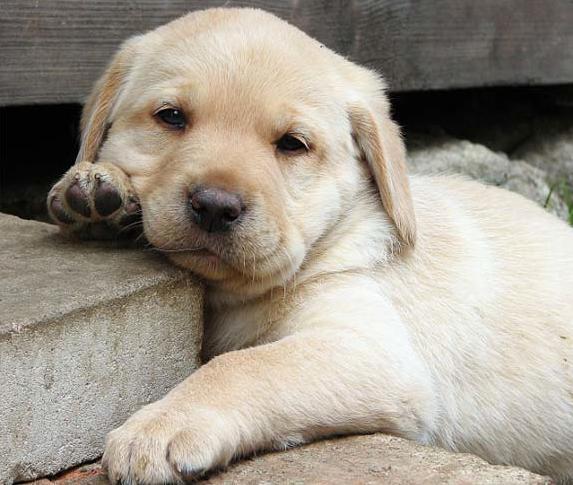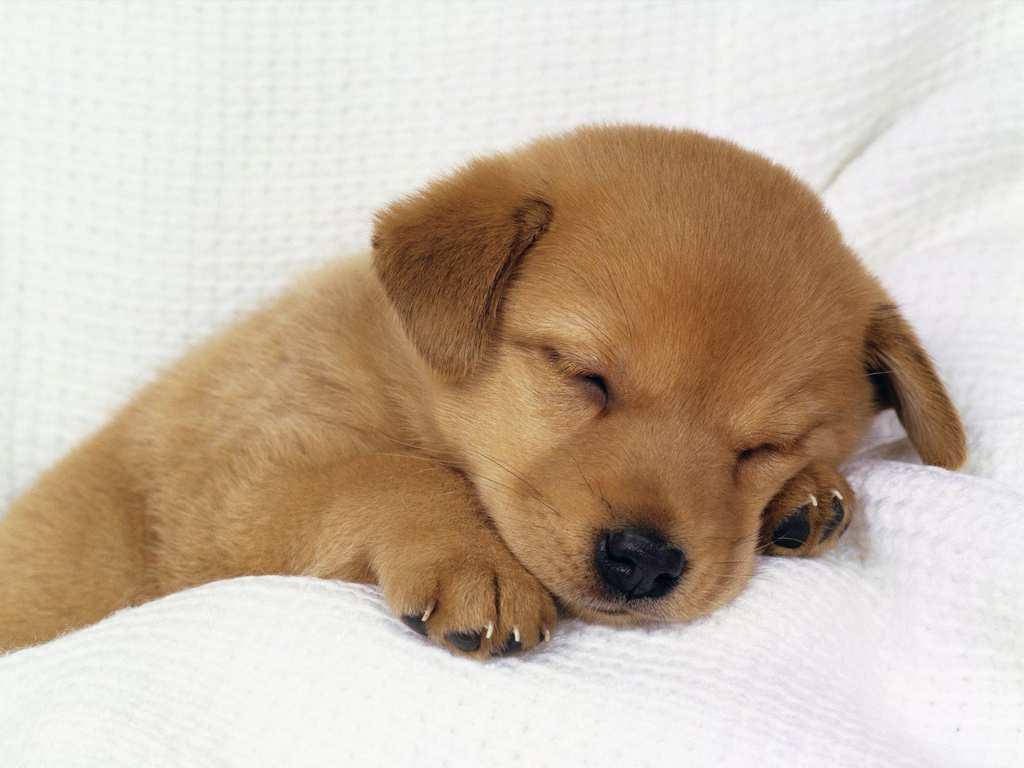The first image is the image on the left, the second image is the image on the right. Evaluate the accuracy of this statement regarding the images: "There are four dogs.". Is it true? Answer yes or no. No. The first image is the image on the left, the second image is the image on the right. Analyze the images presented: Is the assertion "An image shows a row of three dogs, with a black one in the middle." valid? Answer yes or no. No. 